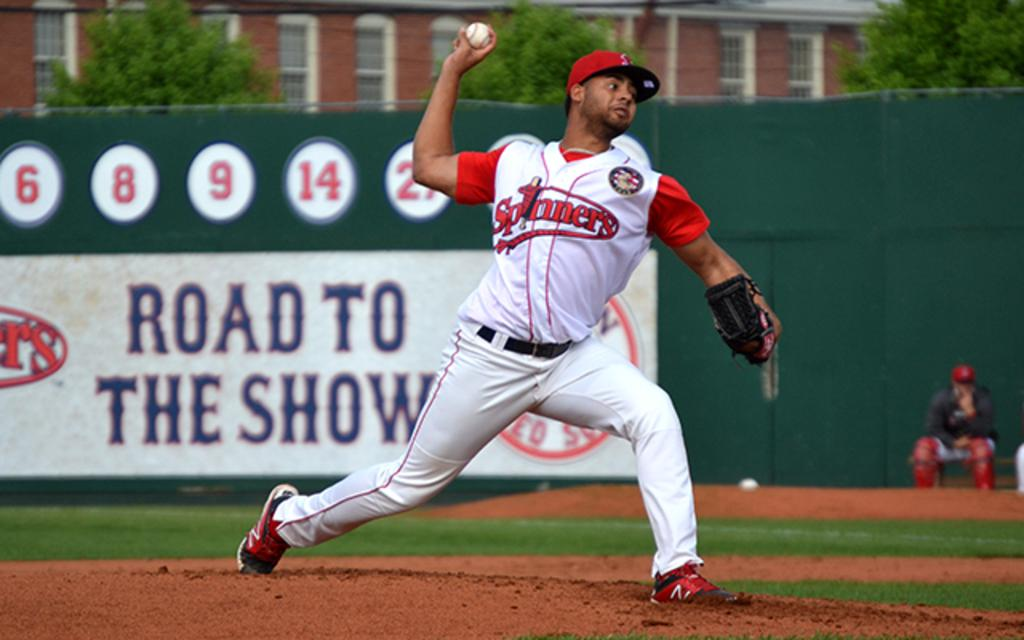<image>
Present a compact description of the photo's key features. A man wears a Spinners baseball uniform on a baseball diamond. 